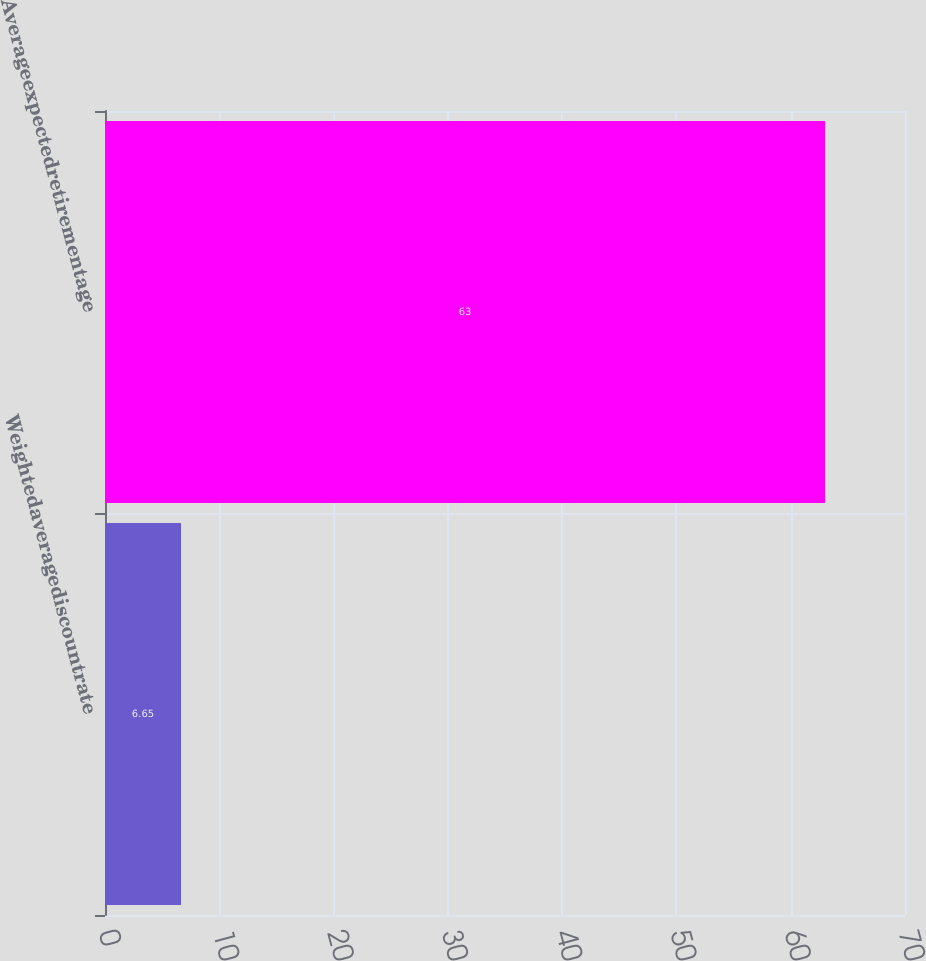Convert chart. <chart><loc_0><loc_0><loc_500><loc_500><bar_chart><fcel>Weightedaveragediscountrate<fcel>Averageexpectedretirementage<nl><fcel>6.65<fcel>63<nl></chart> 